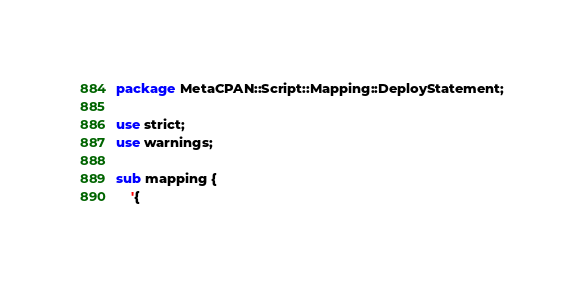Convert code to text. <code><loc_0><loc_0><loc_500><loc_500><_Perl_>package MetaCPAN::Script::Mapping::DeployStatement;

use strict;
use warnings;

sub mapping {
    '{</code> 